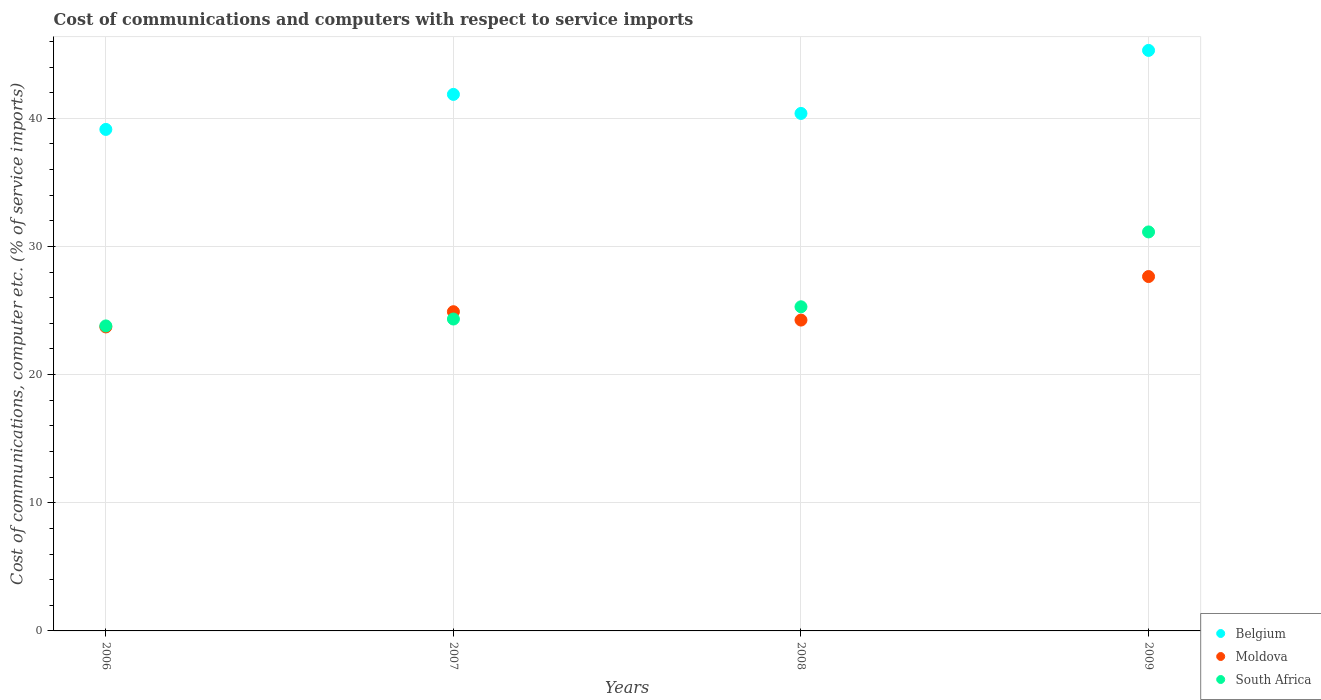What is the cost of communications and computers in South Africa in 2008?
Make the answer very short. 25.29. Across all years, what is the maximum cost of communications and computers in Belgium?
Your answer should be compact. 45.3. Across all years, what is the minimum cost of communications and computers in Moldova?
Offer a terse response. 23.72. In which year was the cost of communications and computers in Belgium minimum?
Provide a succinct answer. 2006. What is the total cost of communications and computers in South Africa in the graph?
Give a very brief answer. 104.57. What is the difference between the cost of communications and computers in Belgium in 2006 and that in 2009?
Ensure brevity in your answer.  -6.17. What is the difference between the cost of communications and computers in South Africa in 2007 and the cost of communications and computers in Moldova in 2009?
Keep it short and to the point. -3.31. What is the average cost of communications and computers in Belgium per year?
Give a very brief answer. 41.67. In the year 2008, what is the difference between the cost of communications and computers in Moldova and cost of communications and computers in South Africa?
Keep it short and to the point. -1.04. In how many years, is the cost of communications and computers in Belgium greater than 30 %?
Ensure brevity in your answer.  4. What is the ratio of the cost of communications and computers in Moldova in 2007 to that in 2009?
Provide a short and direct response. 0.9. Is the cost of communications and computers in Moldova in 2008 less than that in 2009?
Your response must be concise. Yes. What is the difference between the highest and the second highest cost of communications and computers in Belgium?
Your answer should be very brief. 3.43. What is the difference between the highest and the lowest cost of communications and computers in Moldova?
Offer a terse response. 3.93. Is the sum of the cost of communications and computers in South Africa in 2006 and 2008 greater than the maximum cost of communications and computers in Belgium across all years?
Your answer should be very brief. Yes. Is the cost of communications and computers in South Africa strictly greater than the cost of communications and computers in Belgium over the years?
Give a very brief answer. No. How many dotlines are there?
Provide a short and direct response. 3. How many years are there in the graph?
Offer a very short reply. 4. Where does the legend appear in the graph?
Offer a terse response. Bottom right. How are the legend labels stacked?
Offer a very short reply. Vertical. What is the title of the graph?
Provide a succinct answer. Cost of communications and computers with respect to service imports. Does "Middle income" appear as one of the legend labels in the graph?
Your response must be concise. No. What is the label or title of the Y-axis?
Provide a succinct answer. Cost of communications, computer etc. (% of service imports). What is the Cost of communications, computer etc. (% of service imports) of Belgium in 2006?
Offer a very short reply. 39.14. What is the Cost of communications, computer etc. (% of service imports) of Moldova in 2006?
Offer a terse response. 23.72. What is the Cost of communications, computer etc. (% of service imports) of South Africa in 2006?
Offer a very short reply. 23.8. What is the Cost of communications, computer etc. (% of service imports) of Belgium in 2007?
Provide a succinct answer. 41.87. What is the Cost of communications, computer etc. (% of service imports) of Moldova in 2007?
Make the answer very short. 24.91. What is the Cost of communications, computer etc. (% of service imports) in South Africa in 2007?
Ensure brevity in your answer.  24.34. What is the Cost of communications, computer etc. (% of service imports) of Belgium in 2008?
Provide a succinct answer. 40.38. What is the Cost of communications, computer etc. (% of service imports) of Moldova in 2008?
Your response must be concise. 24.26. What is the Cost of communications, computer etc. (% of service imports) of South Africa in 2008?
Provide a short and direct response. 25.29. What is the Cost of communications, computer etc. (% of service imports) of Belgium in 2009?
Your response must be concise. 45.3. What is the Cost of communications, computer etc. (% of service imports) of Moldova in 2009?
Make the answer very short. 27.65. What is the Cost of communications, computer etc. (% of service imports) in South Africa in 2009?
Offer a very short reply. 31.14. Across all years, what is the maximum Cost of communications, computer etc. (% of service imports) in Belgium?
Keep it short and to the point. 45.3. Across all years, what is the maximum Cost of communications, computer etc. (% of service imports) of Moldova?
Offer a terse response. 27.65. Across all years, what is the maximum Cost of communications, computer etc. (% of service imports) of South Africa?
Offer a very short reply. 31.14. Across all years, what is the minimum Cost of communications, computer etc. (% of service imports) in Belgium?
Your response must be concise. 39.14. Across all years, what is the minimum Cost of communications, computer etc. (% of service imports) of Moldova?
Give a very brief answer. 23.72. Across all years, what is the minimum Cost of communications, computer etc. (% of service imports) of South Africa?
Offer a very short reply. 23.8. What is the total Cost of communications, computer etc. (% of service imports) in Belgium in the graph?
Your response must be concise. 166.69. What is the total Cost of communications, computer etc. (% of service imports) in Moldova in the graph?
Offer a very short reply. 100.54. What is the total Cost of communications, computer etc. (% of service imports) in South Africa in the graph?
Your answer should be very brief. 104.57. What is the difference between the Cost of communications, computer etc. (% of service imports) of Belgium in 2006 and that in 2007?
Keep it short and to the point. -2.73. What is the difference between the Cost of communications, computer etc. (% of service imports) of Moldova in 2006 and that in 2007?
Your answer should be compact. -1.19. What is the difference between the Cost of communications, computer etc. (% of service imports) of South Africa in 2006 and that in 2007?
Make the answer very short. -0.54. What is the difference between the Cost of communications, computer etc. (% of service imports) in Belgium in 2006 and that in 2008?
Provide a short and direct response. -1.25. What is the difference between the Cost of communications, computer etc. (% of service imports) of Moldova in 2006 and that in 2008?
Offer a terse response. -0.54. What is the difference between the Cost of communications, computer etc. (% of service imports) of South Africa in 2006 and that in 2008?
Your answer should be compact. -1.49. What is the difference between the Cost of communications, computer etc. (% of service imports) of Belgium in 2006 and that in 2009?
Offer a very short reply. -6.17. What is the difference between the Cost of communications, computer etc. (% of service imports) in Moldova in 2006 and that in 2009?
Your answer should be very brief. -3.93. What is the difference between the Cost of communications, computer etc. (% of service imports) in South Africa in 2006 and that in 2009?
Offer a terse response. -7.33. What is the difference between the Cost of communications, computer etc. (% of service imports) in Belgium in 2007 and that in 2008?
Your answer should be very brief. 1.49. What is the difference between the Cost of communications, computer etc. (% of service imports) in Moldova in 2007 and that in 2008?
Offer a very short reply. 0.65. What is the difference between the Cost of communications, computer etc. (% of service imports) in South Africa in 2007 and that in 2008?
Your response must be concise. -0.96. What is the difference between the Cost of communications, computer etc. (% of service imports) in Belgium in 2007 and that in 2009?
Offer a terse response. -3.43. What is the difference between the Cost of communications, computer etc. (% of service imports) in Moldova in 2007 and that in 2009?
Your response must be concise. -2.74. What is the difference between the Cost of communications, computer etc. (% of service imports) in South Africa in 2007 and that in 2009?
Ensure brevity in your answer.  -6.8. What is the difference between the Cost of communications, computer etc. (% of service imports) of Belgium in 2008 and that in 2009?
Keep it short and to the point. -4.92. What is the difference between the Cost of communications, computer etc. (% of service imports) of Moldova in 2008 and that in 2009?
Keep it short and to the point. -3.4. What is the difference between the Cost of communications, computer etc. (% of service imports) of South Africa in 2008 and that in 2009?
Offer a very short reply. -5.84. What is the difference between the Cost of communications, computer etc. (% of service imports) in Belgium in 2006 and the Cost of communications, computer etc. (% of service imports) in Moldova in 2007?
Provide a short and direct response. 14.23. What is the difference between the Cost of communications, computer etc. (% of service imports) in Belgium in 2006 and the Cost of communications, computer etc. (% of service imports) in South Africa in 2007?
Offer a very short reply. 14.8. What is the difference between the Cost of communications, computer etc. (% of service imports) of Moldova in 2006 and the Cost of communications, computer etc. (% of service imports) of South Africa in 2007?
Offer a very short reply. -0.62. What is the difference between the Cost of communications, computer etc. (% of service imports) of Belgium in 2006 and the Cost of communications, computer etc. (% of service imports) of Moldova in 2008?
Provide a succinct answer. 14.88. What is the difference between the Cost of communications, computer etc. (% of service imports) of Belgium in 2006 and the Cost of communications, computer etc. (% of service imports) of South Africa in 2008?
Keep it short and to the point. 13.84. What is the difference between the Cost of communications, computer etc. (% of service imports) of Moldova in 2006 and the Cost of communications, computer etc. (% of service imports) of South Africa in 2008?
Your response must be concise. -1.57. What is the difference between the Cost of communications, computer etc. (% of service imports) of Belgium in 2006 and the Cost of communications, computer etc. (% of service imports) of Moldova in 2009?
Your answer should be very brief. 11.48. What is the difference between the Cost of communications, computer etc. (% of service imports) of Moldova in 2006 and the Cost of communications, computer etc. (% of service imports) of South Africa in 2009?
Provide a short and direct response. -7.42. What is the difference between the Cost of communications, computer etc. (% of service imports) of Belgium in 2007 and the Cost of communications, computer etc. (% of service imports) of Moldova in 2008?
Make the answer very short. 17.61. What is the difference between the Cost of communications, computer etc. (% of service imports) in Belgium in 2007 and the Cost of communications, computer etc. (% of service imports) in South Africa in 2008?
Your answer should be very brief. 16.57. What is the difference between the Cost of communications, computer etc. (% of service imports) in Moldova in 2007 and the Cost of communications, computer etc. (% of service imports) in South Africa in 2008?
Provide a short and direct response. -0.38. What is the difference between the Cost of communications, computer etc. (% of service imports) in Belgium in 2007 and the Cost of communications, computer etc. (% of service imports) in Moldova in 2009?
Give a very brief answer. 14.21. What is the difference between the Cost of communications, computer etc. (% of service imports) of Belgium in 2007 and the Cost of communications, computer etc. (% of service imports) of South Africa in 2009?
Keep it short and to the point. 10.73. What is the difference between the Cost of communications, computer etc. (% of service imports) in Moldova in 2007 and the Cost of communications, computer etc. (% of service imports) in South Africa in 2009?
Your response must be concise. -6.23. What is the difference between the Cost of communications, computer etc. (% of service imports) in Belgium in 2008 and the Cost of communications, computer etc. (% of service imports) in Moldova in 2009?
Your response must be concise. 12.73. What is the difference between the Cost of communications, computer etc. (% of service imports) in Belgium in 2008 and the Cost of communications, computer etc. (% of service imports) in South Africa in 2009?
Provide a succinct answer. 9.25. What is the difference between the Cost of communications, computer etc. (% of service imports) in Moldova in 2008 and the Cost of communications, computer etc. (% of service imports) in South Africa in 2009?
Your answer should be compact. -6.88. What is the average Cost of communications, computer etc. (% of service imports) in Belgium per year?
Make the answer very short. 41.67. What is the average Cost of communications, computer etc. (% of service imports) in Moldova per year?
Give a very brief answer. 25.14. What is the average Cost of communications, computer etc. (% of service imports) in South Africa per year?
Ensure brevity in your answer.  26.14. In the year 2006, what is the difference between the Cost of communications, computer etc. (% of service imports) of Belgium and Cost of communications, computer etc. (% of service imports) of Moldova?
Provide a short and direct response. 15.41. In the year 2006, what is the difference between the Cost of communications, computer etc. (% of service imports) in Belgium and Cost of communications, computer etc. (% of service imports) in South Africa?
Give a very brief answer. 15.33. In the year 2006, what is the difference between the Cost of communications, computer etc. (% of service imports) of Moldova and Cost of communications, computer etc. (% of service imports) of South Africa?
Provide a short and direct response. -0.08. In the year 2007, what is the difference between the Cost of communications, computer etc. (% of service imports) in Belgium and Cost of communications, computer etc. (% of service imports) in Moldova?
Your answer should be compact. 16.96. In the year 2007, what is the difference between the Cost of communications, computer etc. (% of service imports) of Belgium and Cost of communications, computer etc. (% of service imports) of South Africa?
Offer a terse response. 17.53. In the year 2007, what is the difference between the Cost of communications, computer etc. (% of service imports) in Moldova and Cost of communications, computer etc. (% of service imports) in South Africa?
Ensure brevity in your answer.  0.57. In the year 2008, what is the difference between the Cost of communications, computer etc. (% of service imports) in Belgium and Cost of communications, computer etc. (% of service imports) in Moldova?
Your answer should be compact. 16.12. In the year 2008, what is the difference between the Cost of communications, computer etc. (% of service imports) in Belgium and Cost of communications, computer etc. (% of service imports) in South Africa?
Your answer should be very brief. 15.09. In the year 2008, what is the difference between the Cost of communications, computer etc. (% of service imports) in Moldova and Cost of communications, computer etc. (% of service imports) in South Africa?
Your response must be concise. -1.04. In the year 2009, what is the difference between the Cost of communications, computer etc. (% of service imports) in Belgium and Cost of communications, computer etc. (% of service imports) in Moldova?
Make the answer very short. 17.65. In the year 2009, what is the difference between the Cost of communications, computer etc. (% of service imports) in Belgium and Cost of communications, computer etc. (% of service imports) in South Africa?
Give a very brief answer. 14.17. In the year 2009, what is the difference between the Cost of communications, computer etc. (% of service imports) of Moldova and Cost of communications, computer etc. (% of service imports) of South Africa?
Offer a terse response. -3.48. What is the ratio of the Cost of communications, computer etc. (% of service imports) of Belgium in 2006 to that in 2007?
Offer a terse response. 0.93. What is the ratio of the Cost of communications, computer etc. (% of service imports) in Moldova in 2006 to that in 2007?
Your response must be concise. 0.95. What is the ratio of the Cost of communications, computer etc. (% of service imports) in South Africa in 2006 to that in 2007?
Give a very brief answer. 0.98. What is the ratio of the Cost of communications, computer etc. (% of service imports) in Belgium in 2006 to that in 2008?
Your answer should be very brief. 0.97. What is the ratio of the Cost of communications, computer etc. (% of service imports) in Moldova in 2006 to that in 2008?
Make the answer very short. 0.98. What is the ratio of the Cost of communications, computer etc. (% of service imports) in South Africa in 2006 to that in 2008?
Your response must be concise. 0.94. What is the ratio of the Cost of communications, computer etc. (% of service imports) in Belgium in 2006 to that in 2009?
Ensure brevity in your answer.  0.86. What is the ratio of the Cost of communications, computer etc. (% of service imports) of Moldova in 2006 to that in 2009?
Your answer should be very brief. 0.86. What is the ratio of the Cost of communications, computer etc. (% of service imports) in South Africa in 2006 to that in 2009?
Provide a short and direct response. 0.76. What is the ratio of the Cost of communications, computer etc. (% of service imports) in Belgium in 2007 to that in 2008?
Your answer should be very brief. 1.04. What is the ratio of the Cost of communications, computer etc. (% of service imports) of Moldova in 2007 to that in 2008?
Offer a very short reply. 1.03. What is the ratio of the Cost of communications, computer etc. (% of service imports) of South Africa in 2007 to that in 2008?
Keep it short and to the point. 0.96. What is the ratio of the Cost of communications, computer etc. (% of service imports) in Belgium in 2007 to that in 2009?
Give a very brief answer. 0.92. What is the ratio of the Cost of communications, computer etc. (% of service imports) in Moldova in 2007 to that in 2009?
Keep it short and to the point. 0.9. What is the ratio of the Cost of communications, computer etc. (% of service imports) in South Africa in 2007 to that in 2009?
Your answer should be very brief. 0.78. What is the ratio of the Cost of communications, computer etc. (% of service imports) in Belgium in 2008 to that in 2009?
Offer a terse response. 0.89. What is the ratio of the Cost of communications, computer etc. (% of service imports) of Moldova in 2008 to that in 2009?
Keep it short and to the point. 0.88. What is the ratio of the Cost of communications, computer etc. (% of service imports) in South Africa in 2008 to that in 2009?
Your answer should be very brief. 0.81. What is the difference between the highest and the second highest Cost of communications, computer etc. (% of service imports) in Belgium?
Your answer should be very brief. 3.43. What is the difference between the highest and the second highest Cost of communications, computer etc. (% of service imports) of Moldova?
Provide a succinct answer. 2.74. What is the difference between the highest and the second highest Cost of communications, computer etc. (% of service imports) of South Africa?
Provide a succinct answer. 5.84. What is the difference between the highest and the lowest Cost of communications, computer etc. (% of service imports) of Belgium?
Keep it short and to the point. 6.17. What is the difference between the highest and the lowest Cost of communications, computer etc. (% of service imports) of Moldova?
Provide a succinct answer. 3.93. What is the difference between the highest and the lowest Cost of communications, computer etc. (% of service imports) of South Africa?
Offer a very short reply. 7.33. 